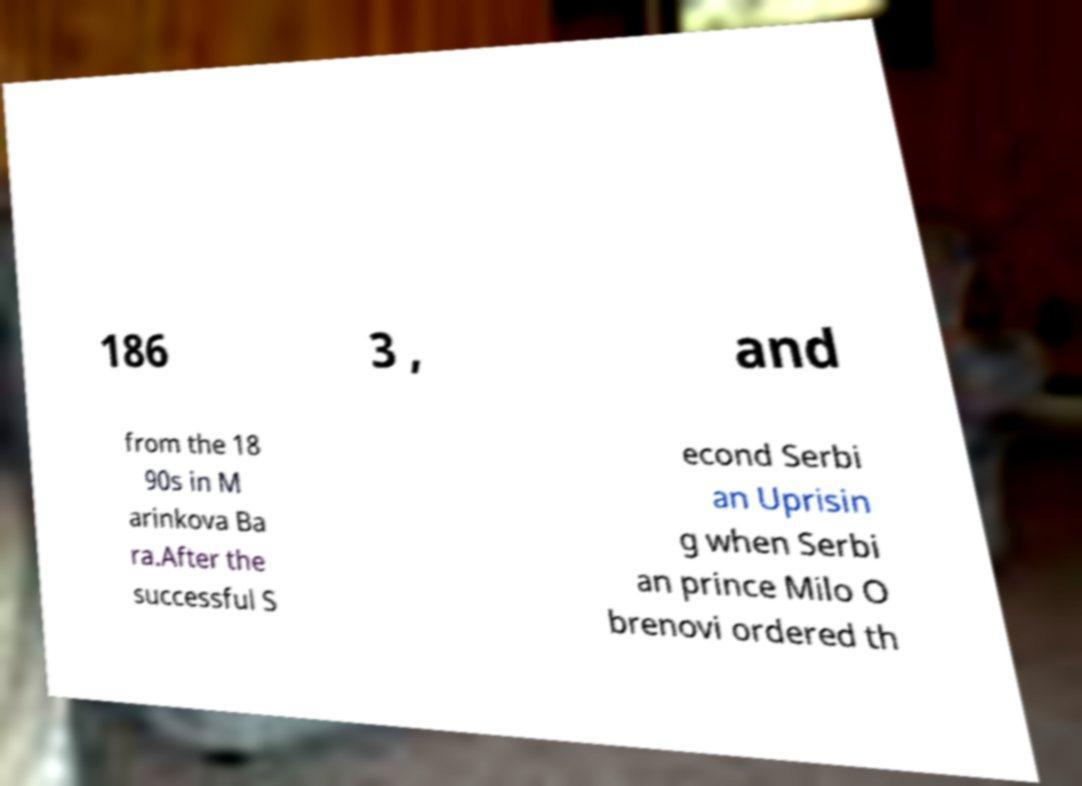Could you assist in decoding the text presented in this image and type it out clearly? 186 3 , and from the 18 90s in M arinkova Ba ra.After the successful S econd Serbi an Uprisin g when Serbi an prince Milo O brenovi ordered th 